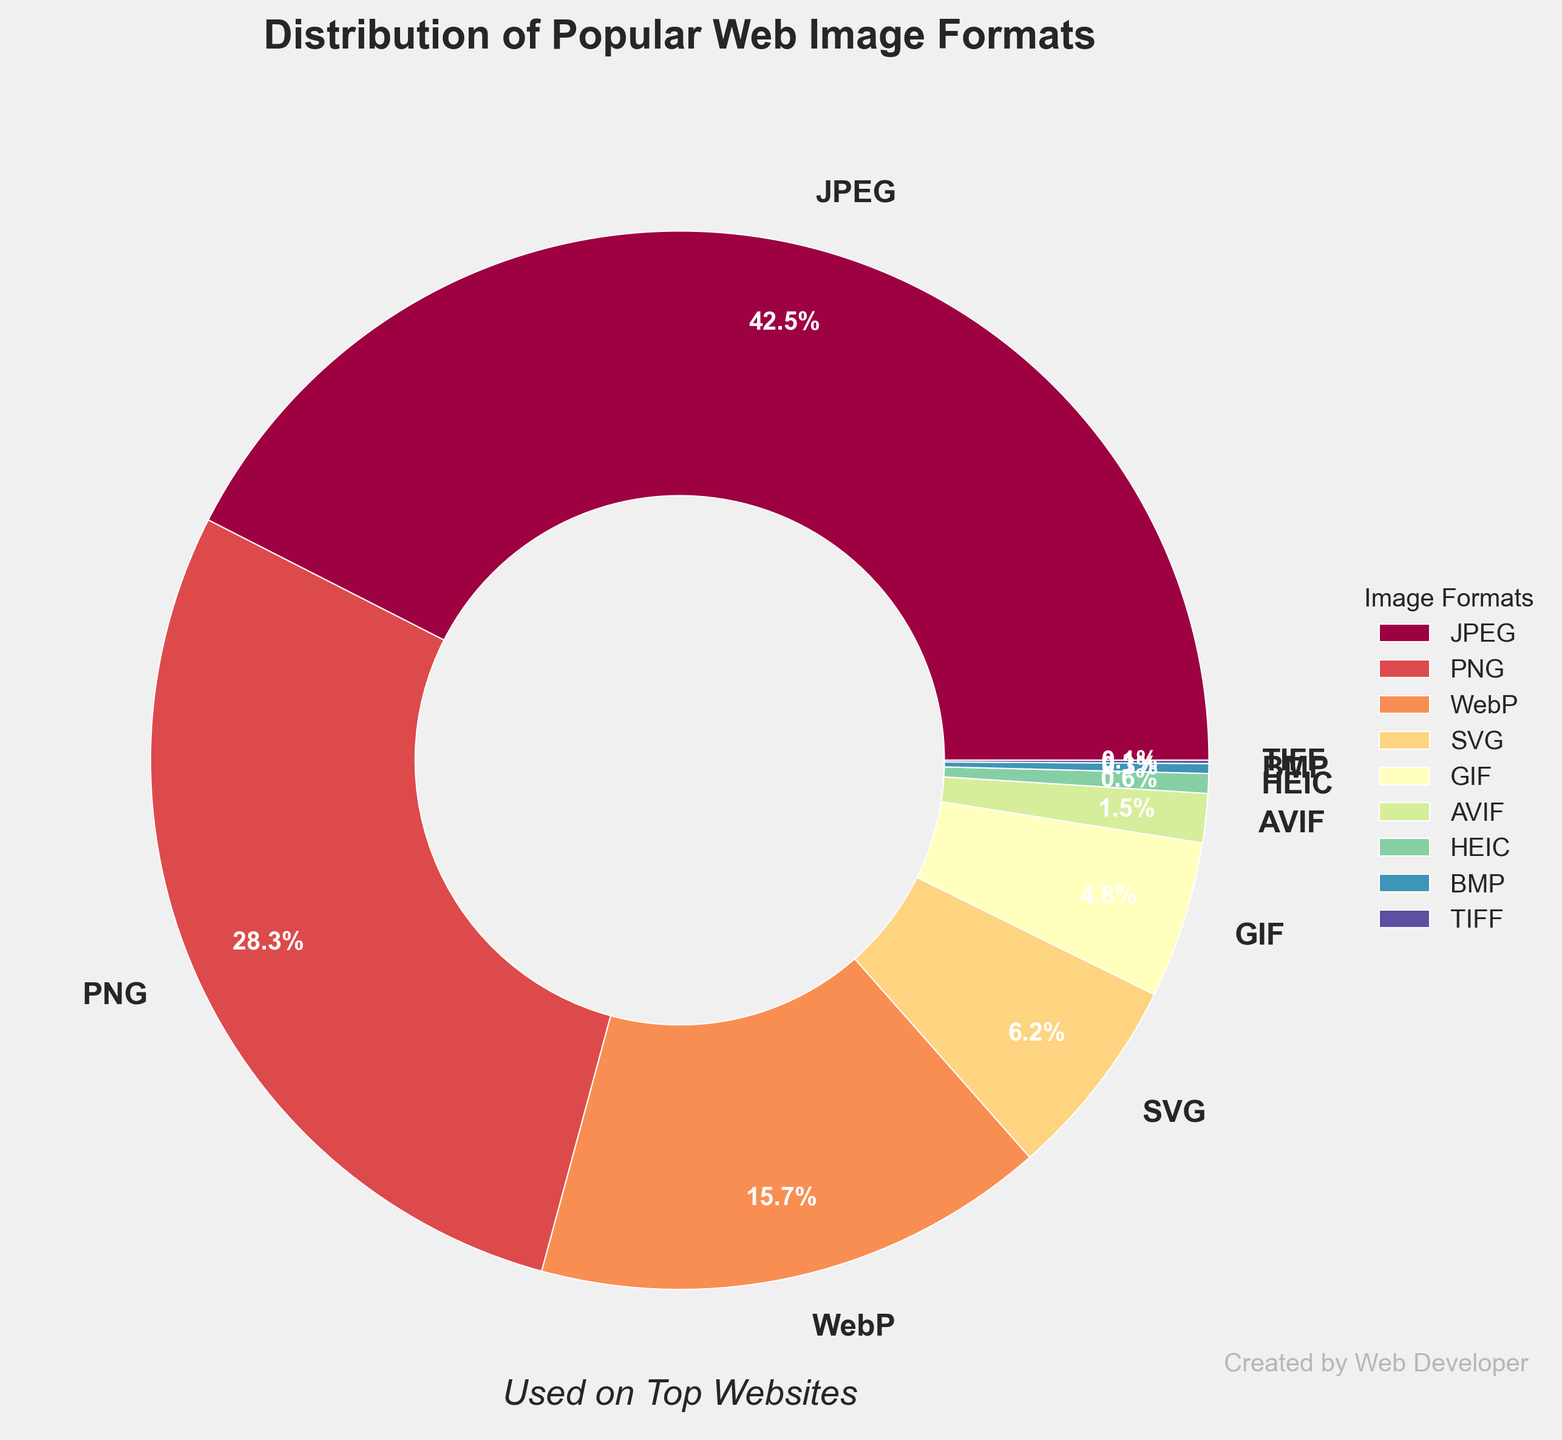Which image format has the highest usage percentage and what is it? By looking at the figure, identify the slice of the pie chart that represents the largest percentage and its associated label. It is at the top portion of the chart labeled "JPEG" with 42.5%.
Answer: JPEG, 42.5% What is the combined usage percentage of GIF and SVG formats? Locate the slices labeled "GIF" and "SVG" in the pie chart and sum their percentages: GIF (4.8%) + SVG (6.2%) = 11.0%.
Answer: 11.0% Which image formats have a usage percentage less than 1%? Find the slices in the pie chart with percentages less than 1%. The slices labeled "AVIF" (1.5%), "HEIC" (0.6%), "BMP" (0.3%), and "TIFF" (0.1%) satisfy this condition.
Answer: AVIF, HEIC, BMP, TIFF How does the usage of WebP compare to that of PNG? Identify the slices for "WebP" and "PNG" and compare their values. WebP has 15.7% and PNG has 28.3%. WebP's usage is less than that of PNG.
Answer: WebP < PNG If you sum up the percentages of WebP, SVG, and GIF, do they exceed the usage of JPEG? Add the percentages for WebP (15.7%), SVG (6.2%), and GIF (4.8%) and compare with JPEG (42.5%): 15.7% + 6.2% + 4.8% = 26.7%, which is less than 42.5%.
Answer: No What is the difference in usage between JPEG and the combination of PNG and SVG? Calculate the total percentage of PNG and SVG (28.3% + 6.2% = 34.5%) and subtract it from JPEG (42.5%). The difference is 42.5% - 34.5% = 8.0%.
Answer: 8.0% What is the color of the wedge representing AVIF on the pie chart? Examine the pie chart and identify the color of the slice labeled "AVIF". It appears in a specific color (students should identify this visually).
Answer: (visual identification required) Which image format has the smallest usage percentage and what is it? Look at the pie chart to identify the smallest slice by percentage. It is labeled "TIFF" with 0.1%.
Answer: TIFF, 0.1% 